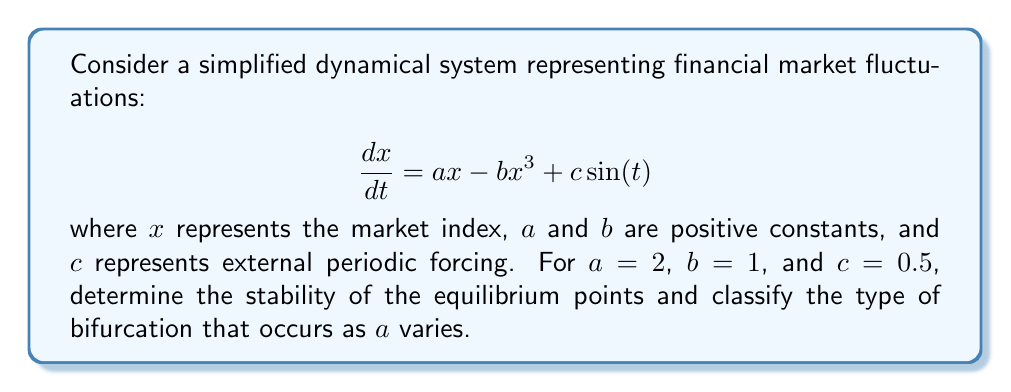Show me your answer to this math problem. 1. First, we find the equilibrium points by setting $\frac{dx}{dt} = 0$ and ignoring the periodic forcing term:

   $$ax - bx^3 = 0$$
   $$x(a - bx^2) = 0$$

2. Solving this equation gives us three equilibrium points:
   $$x_1 = 0, x_2 = +\sqrt{\frac{a}{b}}, x_3 = -\sqrt{\frac{a}{b}}$$

3. For $a=2$ and $b=1$, the equilibrium points are:
   $$x_1 = 0, x_2 = +\sqrt{2}, x_3 = -\sqrt{2}$$

4. To determine stability, we calculate the Jacobian:
   $$J = \frac{\partial}{\partial x}(ax - bx^3) = a - 3bx^2$$

5. Evaluating the Jacobian at each equilibrium point:
   - At $x_1 = 0$: $J_1 = a = 2$ (unstable)
   - At $x_2 = +\sqrt{2}$: $J_2 = a - 3b(\sqrt{2})^2 = 2 - 6 = -4$ (stable)
   - At $x_3 = -\sqrt{2}$: $J_3 = a - 3b(\sqrt{2})^2 = 2 - 6 = -4$ (stable)

6. As $a$ varies, we observe a pitchfork bifurcation:
   - For $a < 0$, there is one stable equilibrium point at $x = 0$.
   - At $a = 0$, a pitchfork bifurcation occurs.
   - For $a > 0$, $x = 0$ becomes unstable, and two stable equilibrium points emerge at $\pm\sqrt{\frac{a}{b}}$.

7. The periodic forcing term $c\sin(t)$ adds oscillations around these equilibrium points but does not change their stability for small $c$.
Answer: Pitchfork bifurcation; $x_1 = 0$ (unstable), $x_2 = +\sqrt{2}$ (stable), $x_3 = -\sqrt{2}$ (stable) 